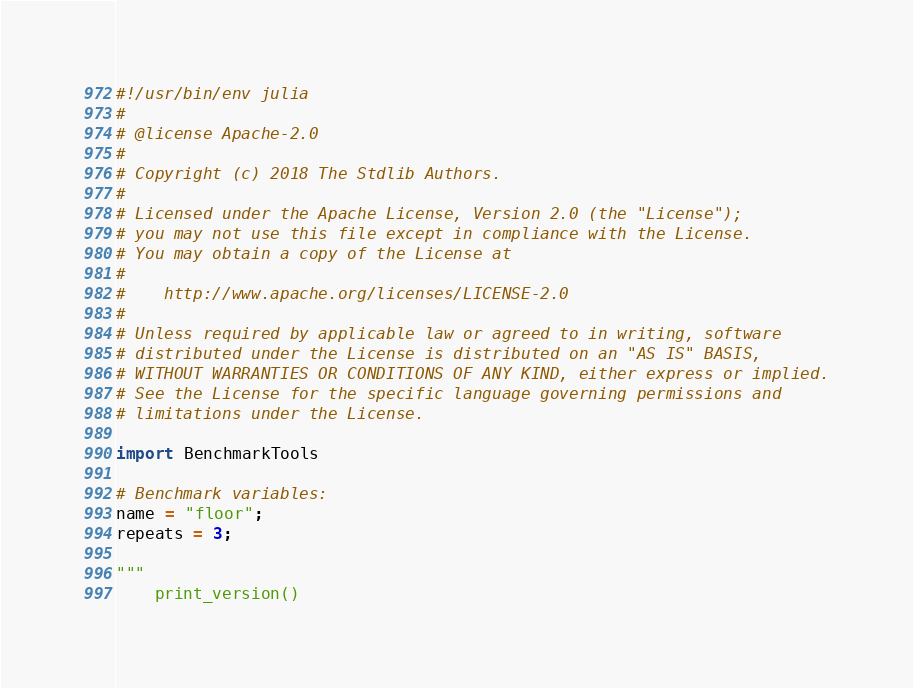<code> <loc_0><loc_0><loc_500><loc_500><_Julia_>#!/usr/bin/env julia
#
# @license Apache-2.0
#
# Copyright (c) 2018 The Stdlib Authors.
#
# Licensed under the Apache License, Version 2.0 (the "License");
# you may not use this file except in compliance with the License.
# You may obtain a copy of the License at
#
#    http://www.apache.org/licenses/LICENSE-2.0
#
# Unless required by applicable law or agreed to in writing, software
# distributed under the License is distributed on an "AS IS" BASIS,
# WITHOUT WARRANTIES OR CONDITIONS OF ANY KIND, either express or implied.
# See the License for the specific language governing permissions and
# limitations under the License.

import BenchmarkTools

# Benchmark variables:
name = "floor";
repeats = 3;

"""
	print_version()
</code> 